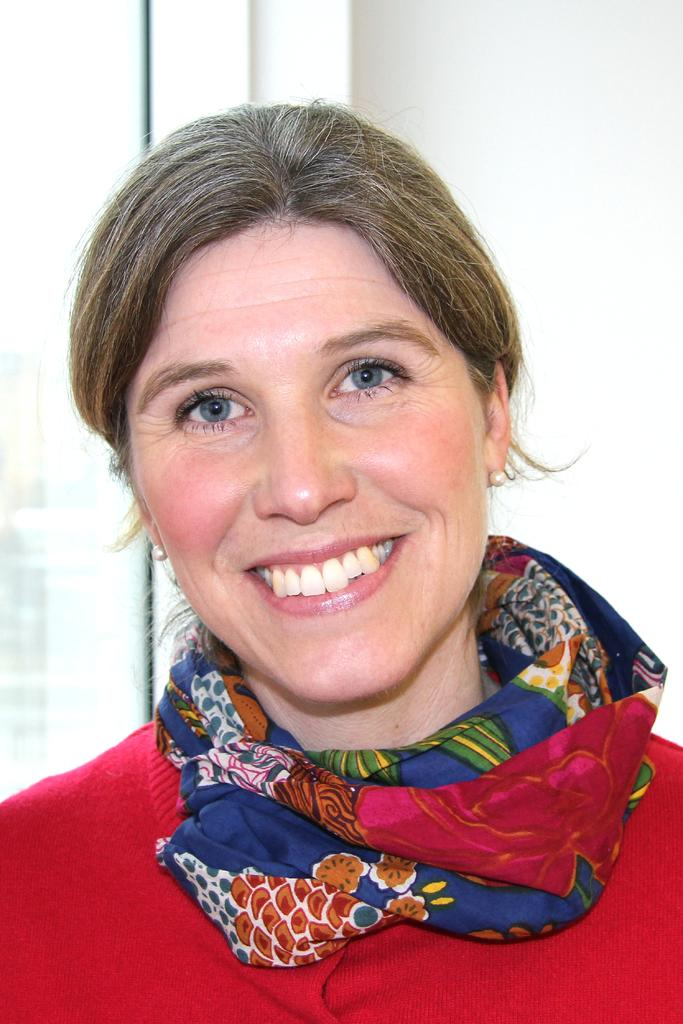What is the main subject of the image? The main subject of the image is a woman. What is the woman doing in the image? The woman is smiling in the image. What is the woman wearing in the image? The woman is wearing a red dress in the image. How many sticks does the woman have in her hair in the image? There are no sticks visible in the woman's hair in the image. What is the woman's annual income in the image? The image does not provide any information about the woman's income. 